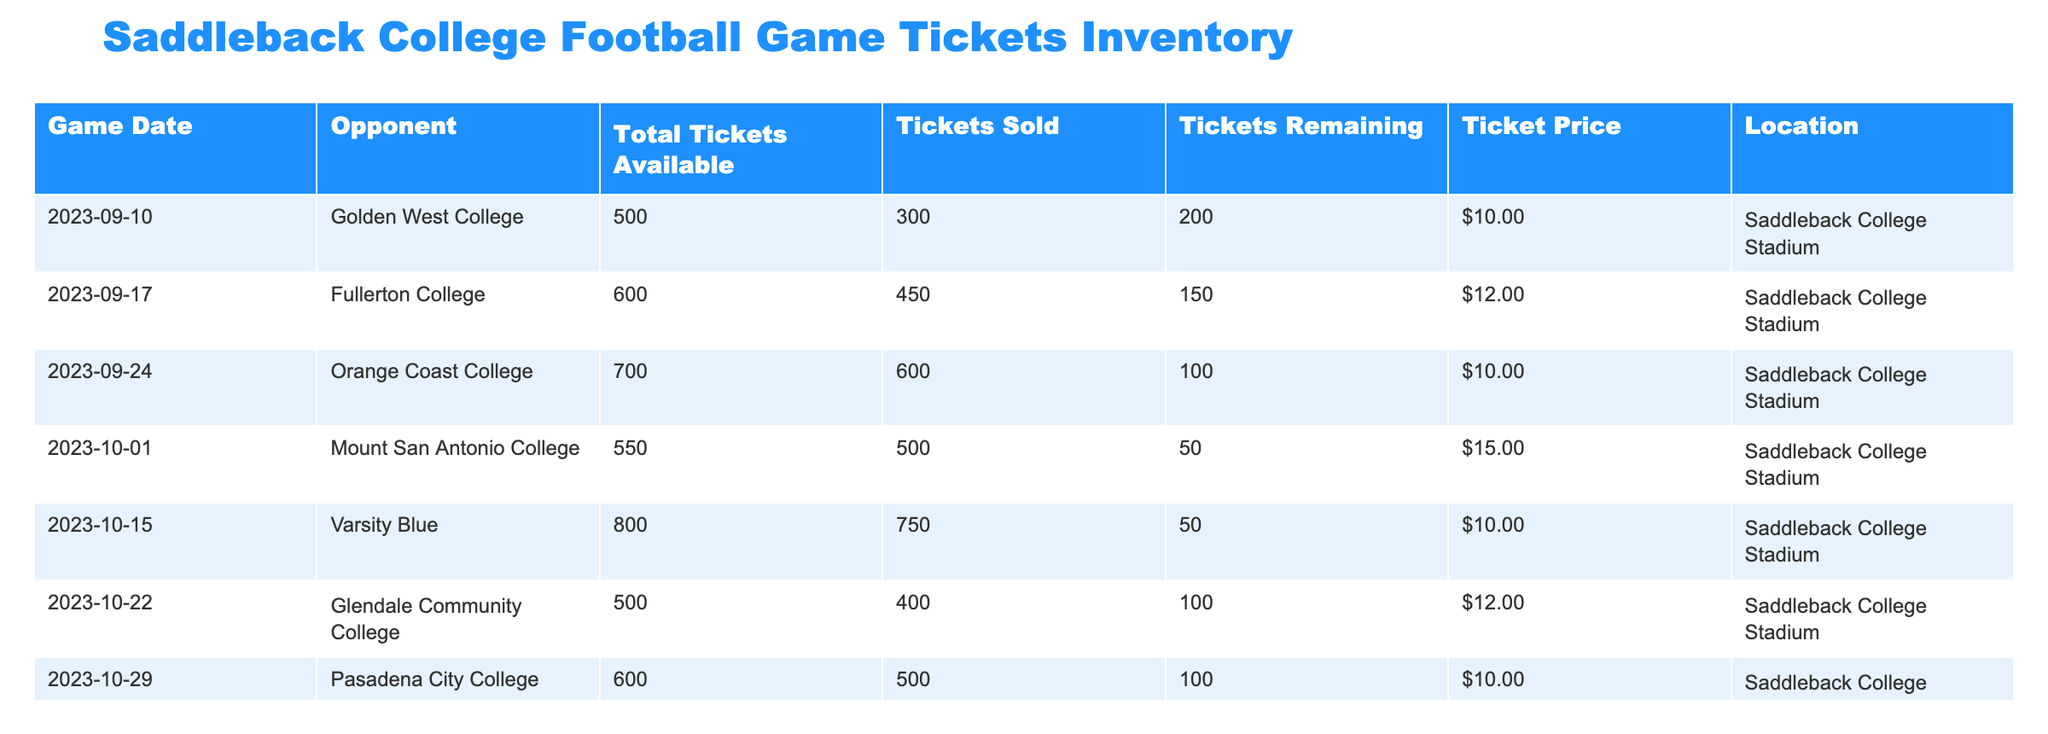What is the total number of tickets available for the game against Fullerton College? The table indicates the total tickets available for each game. For the game against Fullerton College, the total number listed is 600.
Answer: 600 How many tickets were remaining for the game against Pasadena City College? The table shows the tickets remaining for each game. For the Pasadena City College game, the remaining tickets are noted as 100.
Answer: 100 Is the ticket price for the game against Golden West College higher than that for the game against Orange Coast College? The ticket price for the Golden West College game is $10, whereas for the Orange Coast College game, it is also $10. Therefore, the statement is false as both prices are the same.
Answer: No What is the average number of tickets sold for all games listed? To find the average, add the tickets sold for each game (300 + 450 + 600 + 500 + 750 + 400 + 500 = 3450) and divide by the number of games (7). 3450 / 7 gives approximately 492.86, which rounds to 493.
Answer: 493 For which opponent was the lowest number of tickets remaining and how many were there? By examining the 'Tickets Remaining' column, the lowest number is 50, which applies to both Mount San Antonio College and Varsity Blue games.
Answer: Mount San Antonio College and Varsity Blue, 50 What is the total revenue generated from ticket sales for the game against Glendale Community College? For the Glendale Community College game, the ticket price is $12 and 400 tickets were sold. Therefore, total revenue is calculated as 400 tickets sold multiplied by $12 which equals $4800.
Answer: $4800 Are there more total tickets available for the game against Varsity Blue than for the game against Mount San Antonio College? The table shows that there are 800 total tickets available for Varsity Blue and 550 for Mount San Antonio College. So, the statement is true because 800 is greater than 550.
Answer: Yes What percentage of tickets were sold for the game against Orange Coast College? The total tickets available for the Orange Coast College game are 700, and tickets sold are 600. The percentage sold is calculated as (600 / 700) * 100, resulting in approximately 85.71%.
Answer: 85.71% Which game had the highest ticket price and what was it? By examining the 'Ticket Price' column, the highest price listed is $15 for the game against Mount San Antonio College.
Answer: Mount San Antonio College, $15 